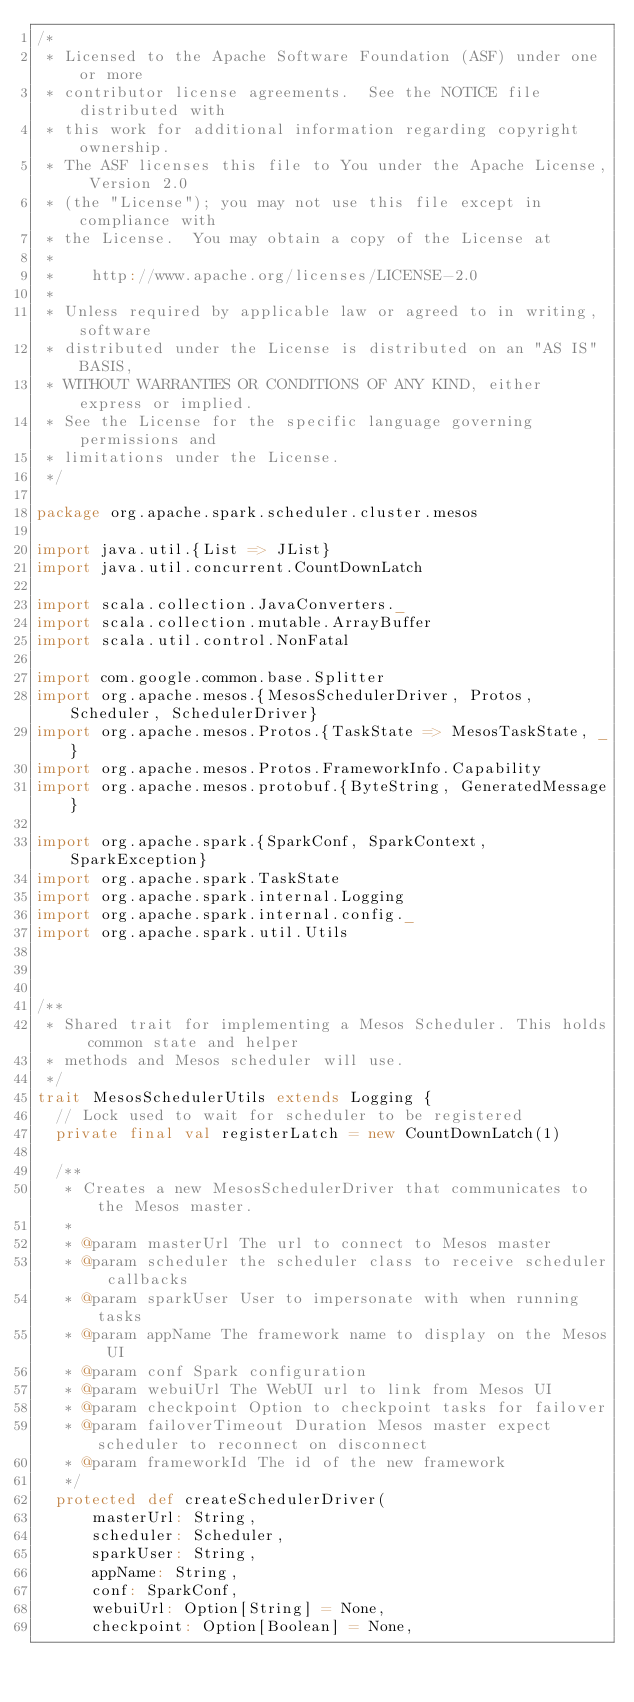<code> <loc_0><loc_0><loc_500><loc_500><_Scala_>/*
 * Licensed to the Apache Software Foundation (ASF) under one or more
 * contributor license agreements.  See the NOTICE file distributed with
 * this work for additional information regarding copyright ownership.
 * The ASF licenses this file to You under the Apache License, Version 2.0
 * (the "License"); you may not use this file except in compliance with
 * the License.  You may obtain a copy of the License at
 *
 *    http://www.apache.org/licenses/LICENSE-2.0
 *
 * Unless required by applicable law or agreed to in writing, software
 * distributed under the License is distributed on an "AS IS" BASIS,
 * WITHOUT WARRANTIES OR CONDITIONS OF ANY KIND, either express or implied.
 * See the License for the specific language governing permissions and
 * limitations under the License.
 */

package org.apache.spark.scheduler.cluster.mesos

import java.util.{List => JList}
import java.util.concurrent.CountDownLatch

import scala.collection.JavaConverters._
import scala.collection.mutable.ArrayBuffer
import scala.util.control.NonFatal

import com.google.common.base.Splitter
import org.apache.mesos.{MesosSchedulerDriver, Protos, Scheduler, SchedulerDriver}
import org.apache.mesos.Protos.{TaskState => MesosTaskState, _}
import org.apache.mesos.Protos.FrameworkInfo.Capability
import org.apache.mesos.protobuf.{ByteString, GeneratedMessage}

import org.apache.spark.{SparkConf, SparkContext, SparkException}
import org.apache.spark.TaskState
import org.apache.spark.internal.Logging
import org.apache.spark.internal.config._
import org.apache.spark.util.Utils



/**
 * Shared trait for implementing a Mesos Scheduler. This holds common state and helper
 * methods and Mesos scheduler will use.
 */
trait MesosSchedulerUtils extends Logging {
  // Lock used to wait for scheduler to be registered
  private final val registerLatch = new CountDownLatch(1)

  /**
   * Creates a new MesosSchedulerDriver that communicates to the Mesos master.
   *
   * @param masterUrl The url to connect to Mesos master
   * @param scheduler the scheduler class to receive scheduler callbacks
   * @param sparkUser User to impersonate with when running tasks
   * @param appName The framework name to display on the Mesos UI
   * @param conf Spark configuration
   * @param webuiUrl The WebUI url to link from Mesos UI
   * @param checkpoint Option to checkpoint tasks for failover
   * @param failoverTimeout Duration Mesos master expect scheduler to reconnect on disconnect
   * @param frameworkId The id of the new framework
   */
  protected def createSchedulerDriver(
      masterUrl: String,
      scheduler: Scheduler,
      sparkUser: String,
      appName: String,
      conf: SparkConf,
      webuiUrl: Option[String] = None,
      checkpoint: Option[Boolean] = None,</code> 